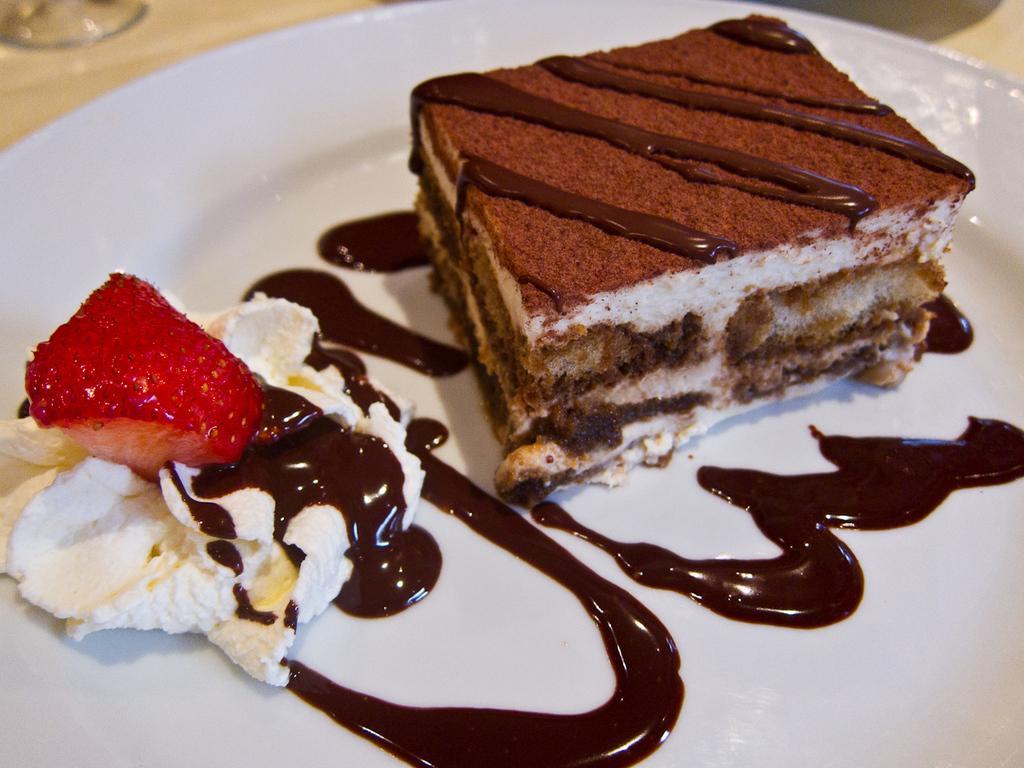How would you summarize this image in a sentence or two? In this image there is a piece of cake and there is some sauce at left side of this image are kept in a white color plate as we can see in middle of this image. 